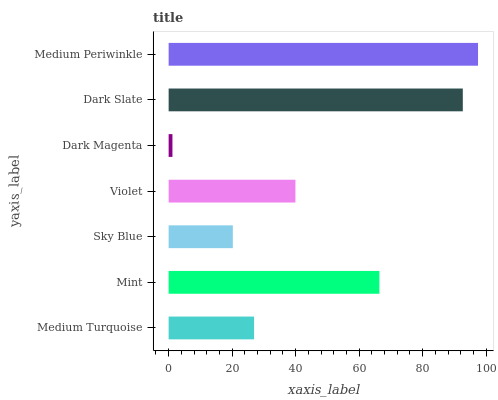Is Dark Magenta the minimum?
Answer yes or no. Yes. Is Medium Periwinkle the maximum?
Answer yes or no. Yes. Is Mint the minimum?
Answer yes or no. No. Is Mint the maximum?
Answer yes or no. No. Is Mint greater than Medium Turquoise?
Answer yes or no. Yes. Is Medium Turquoise less than Mint?
Answer yes or no. Yes. Is Medium Turquoise greater than Mint?
Answer yes or no. No. Is Mint less than Medium Turquoise?
Answer yes or no. No. Is Violet the high median?
Answer yes or no. Yes. Is Violet the low median?
Answer yes or no. Yes. Is Mint the high median?
Answer yes or no. No. Is Medium Turquoise the low median?
Answer yes or no. No. 